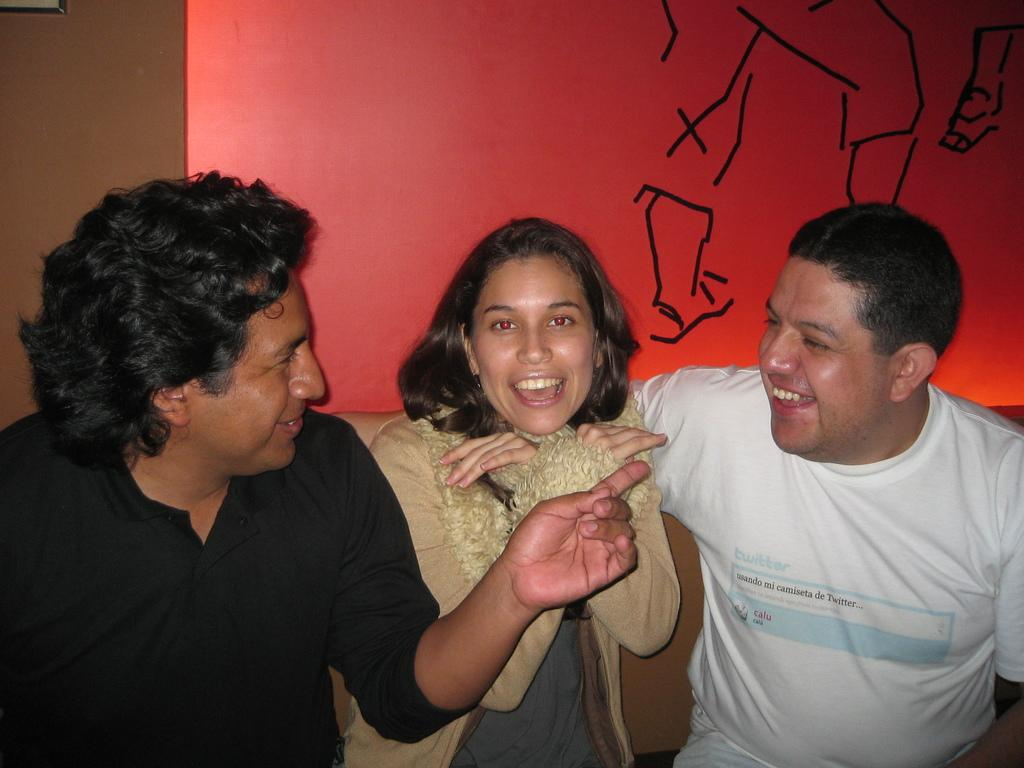How many people are in the image? There are three people in the image: two men and a woman. What is the facial expression of the people in the image? The people in the image are smiling. What can be seen in the background of the image? There is a red color wall in the background. What is depicted on the wall in the image? The wall has a painting of a person. What type of salt is being used to season the food in the image? There is no food or salt present in the image; it features three people smiling with a painting on the wall in the background. Is there a rabbit hiding behind the woman in the image? There is no rabbit present in the image; it only features three people and a painting on the wall. 